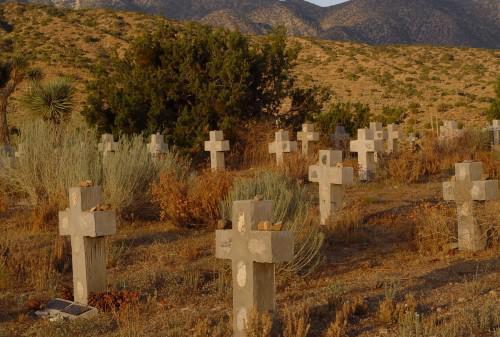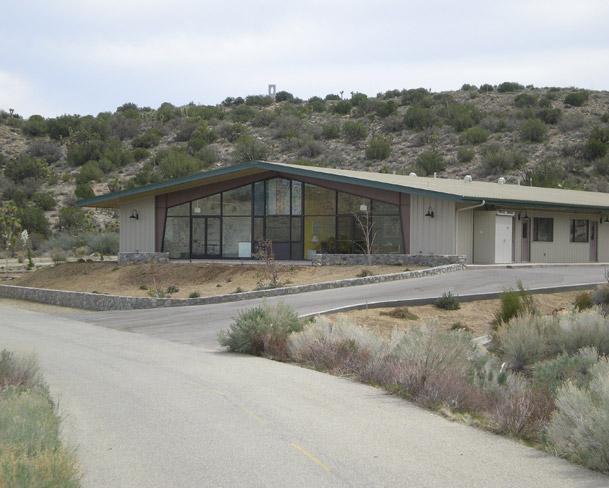The first image is the image on the left, the second image is the image on the right. Considering the images on both sides, is "There is a body of water on the images." valid? Answer yes or no. No. 